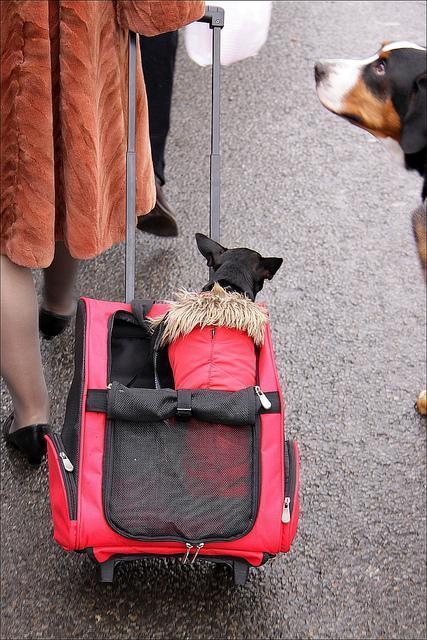How many human legs do you see?
Give a very brief answer. 3. How many people are there?
Give a very brief answer. 2. How many dogs can you see?
Give a very brief answer. 2. How many elephants have riders on them?
Give a very brief answer. 0. 